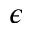Convert formula to latex. <formula><loc_0><loc_0><loc_500><loc_500>\epsilon</formula> 